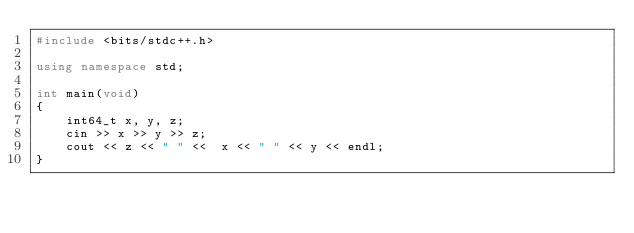Convert code to text. <code><loc_0><loc_0><loc_500><loc_500><_C++_>#include <bits/stdc++.h>

using namespace std;

int main(void)
{
    int64_t x, y, z;
    cin >> x >> y >> z;
    cout << z << " " <<  x << " " << y << endl;
}</code> 